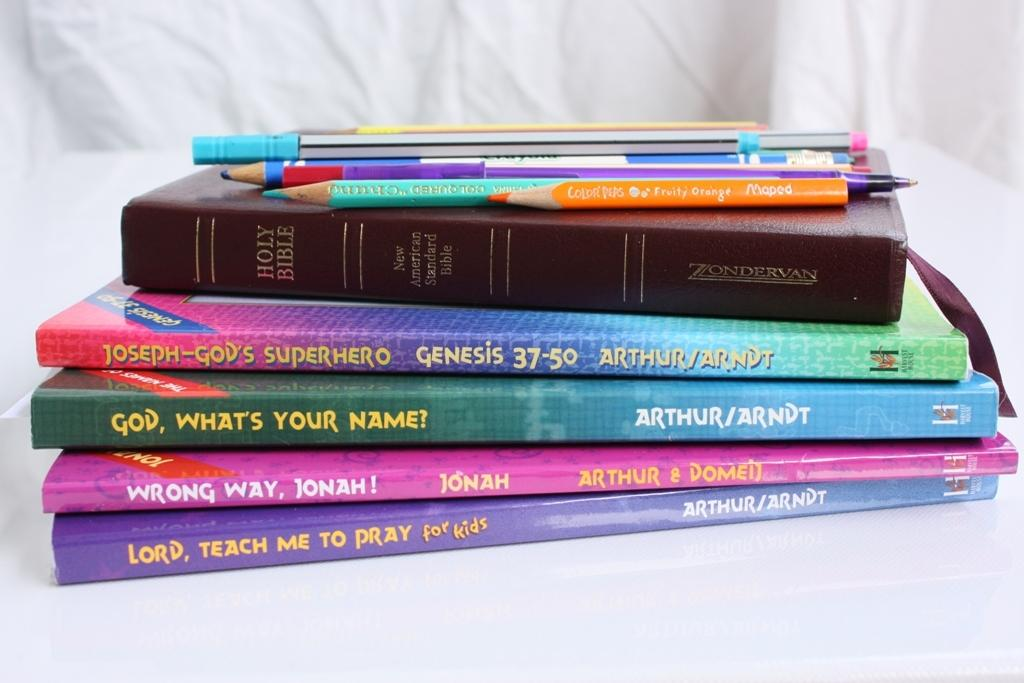Provide a one-sentence caption for the provided image. A book titled God What's Your Name? is sitting in the middle of other religious books. 